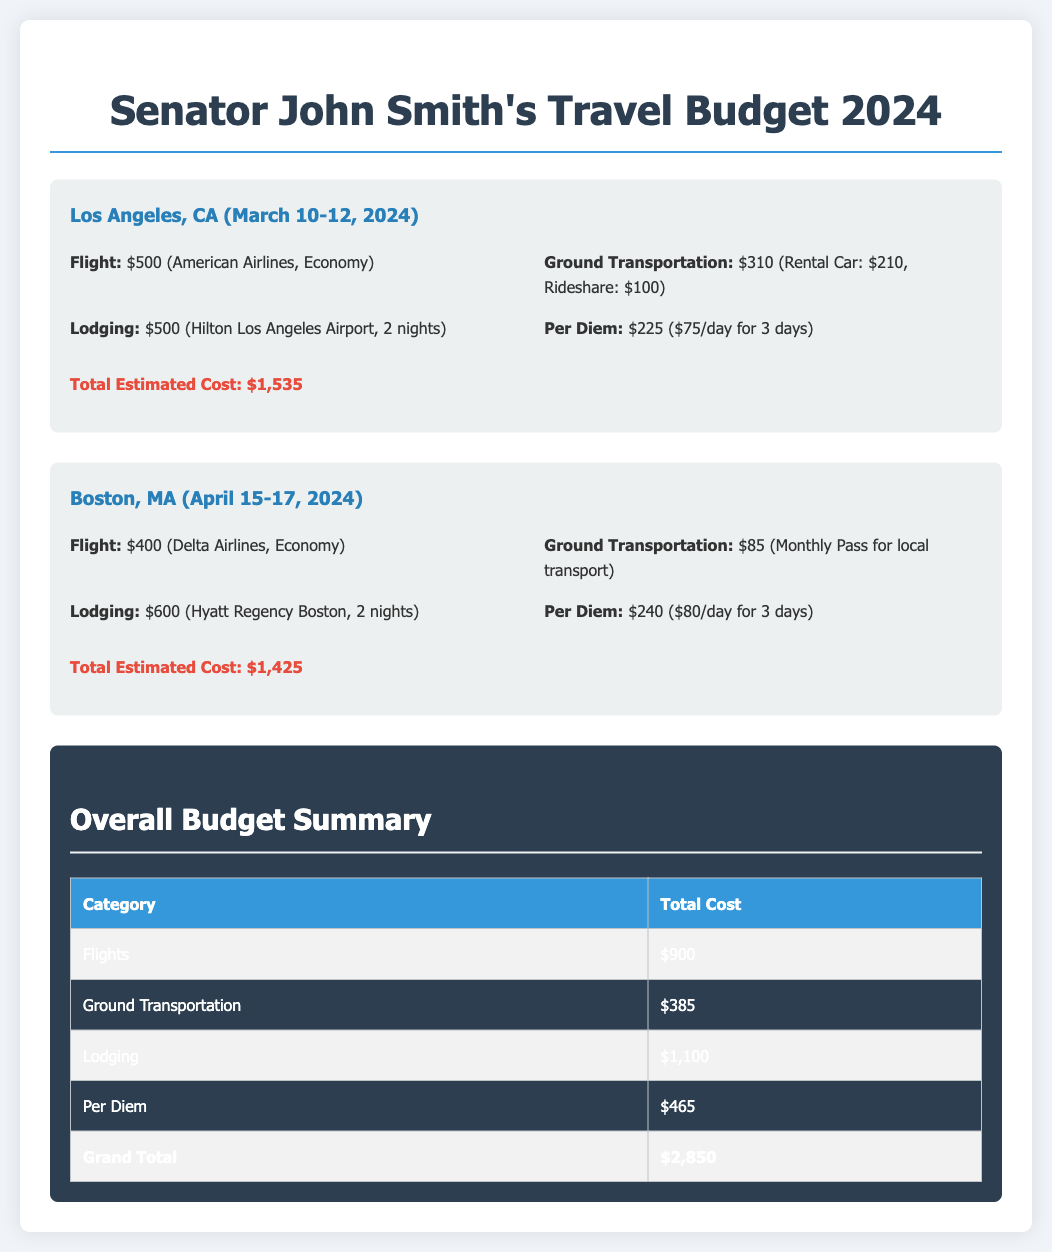What is the total estimated cost for the Los Angeles trip? The total estimated cost for the Los Angeles trip is stated as $1,535.
Answer: $1,535 What are the dates for the Boston visit? The dates for the Boston visit are mentioned as April 15-17, 2024.
Answer: April 15-17, 2024 How much is the per diem for the Boston trip? The per diem for the Boston trip is calculated as $80 per day for 3 days, totaling $240.
Answer: $240 What is the lodging cost for the Los Angeles trip? The lodging cost for the Los Angeles trip is specified as $500 for 2 nights at the Hilton Los Angeles Airport.
Answer: $500 Which airline is used for the Los Angeles flight? The airline used for the Los Angeles flight is American Airlines.
Answer: American Airlines What is the grand total for the overall budget? The grand total for the overall budget is summarized as $2,850.
Answer: $2,850 What is the total cost for flights? The total cost for flights is listed as $900, incorporating the expenses from both trips.
Answer: $900 How much was spent on ground transportation for the Boston trip? The ground transportation for the Boston trip costs $85 for a monthly pass.
Answer: $85 How many nights will the Senator stay in Boston? The document indicates that the Senator will stay in Boston for 2 nights.
Answer: 2 nights 